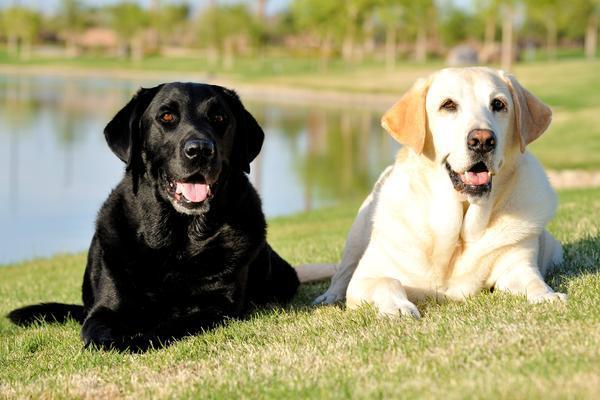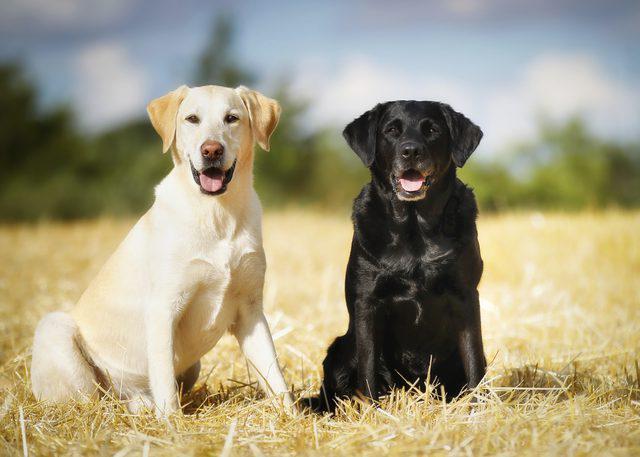The first image is the image on the left, the second image is the image on the right. For the images shown, is this caption "An image contains exactly two dogs sitting upright, with the darker dog on the right." true? Answer yes or no. Yes. The first image is the image on the left, the second image is the image on the right. Given the left and right images, does the statement "Four dogs exactly can be seen on the pair of images." hold true? Answer yes or no. Yes. 